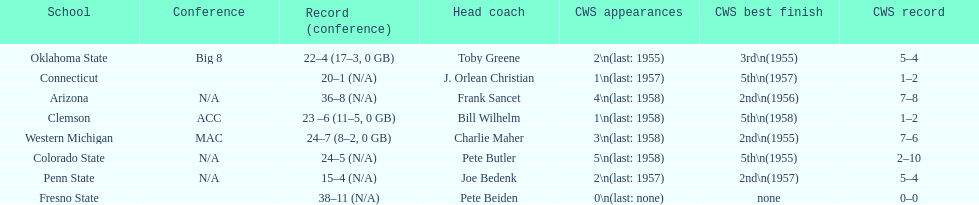Oklahoma state and penn state both have how many cws appearances? 2. 